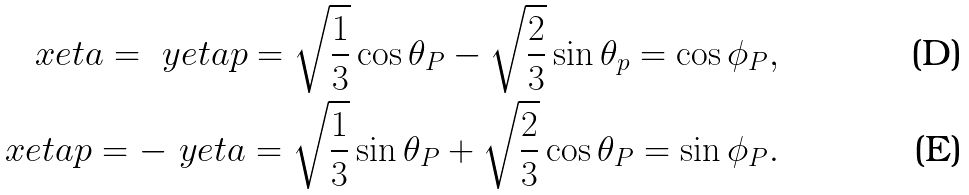Convert formula to latex. <formula><loc_0><loc_0><loc_500><loc_500>\ x e t a = \ y e t a p = \sqrt { \frac { 1 } { 3 } } \cos \theta _ { P } - \sqrt { \frac { 2 } { 3 } } \sin \theta _ { p } = \cos \phi _ { P } , \\ \ x e t a p = - \ y e t a = \sqrt { \frac { 1 } { 3 } } \sin \theta _ { P } + \sqrt { \frac { 2 } { 3 } } \cos \theta _ { P } = \sin \phi _ { P } .</formula> 